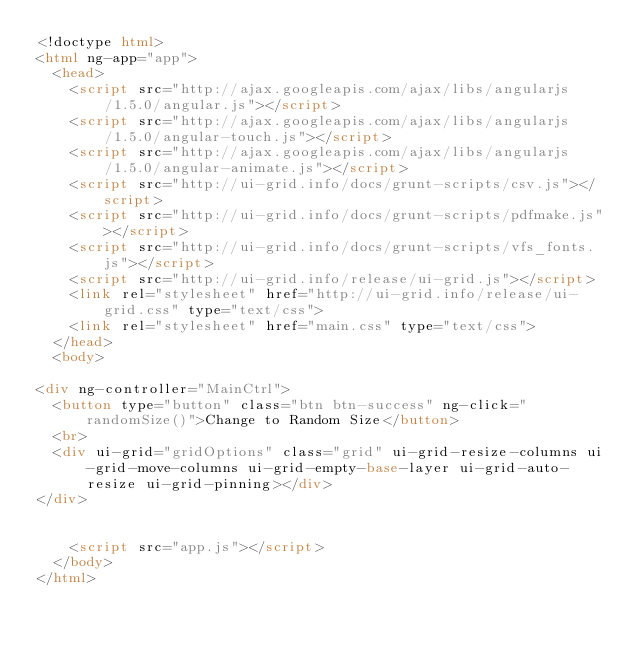Convert code to text. <code><loc_0><loc_0><loc_500><loc_500><_HTML_><!doctype html>
<html ng-app="app">
  <head>
    <script src="http://ajax.googleapis.com/ajax/libs/angularjs/1.5.0/angular.js"></script>
    <script src="http://ajax.googleapis.com/ajax/libs/angularjs/1.5.0/angular-touch.js"></script>
    <script src="http://ajax.googleapis.com/ajax/libs/angularjs/1.5.0/angular-animate.js"></script>
    <script src="http://ui-grid.info/docs/grunt-scripts/csv.js"></script>
    <script src="http://ui-grid.info/docs/grunt-scripts/pdfmake.js"></script>
    <script src="http://ui-grid.info/docs/grunt-scripts/vfs_fonts.js"></script>
    <script src="http://ui-grid.info/release/ui-grid.js"></script>
    <link rel="stylesheet" href="http://ui-grid.info/release/ui-grid.css" type="text/css">
    <link rel="stylesheet" href="main.css" type="text/css">
  </head>
  <body>

<div ng-controller="MainCtrl">
  <button type="button" class="btn btn-success" ng-click="randomSize()">Change to Random Size</button>
  <br>
  <div ui-grid="gridOptions" class="grid" ui-grid-resize-columns ui-grid-move-columns ui-grid-empty-base-layer ui-grid-auto-resize ui-grid-pinning></div>
</div>


    <script src="app.js"></script>
  </body>
</html>
</code> 